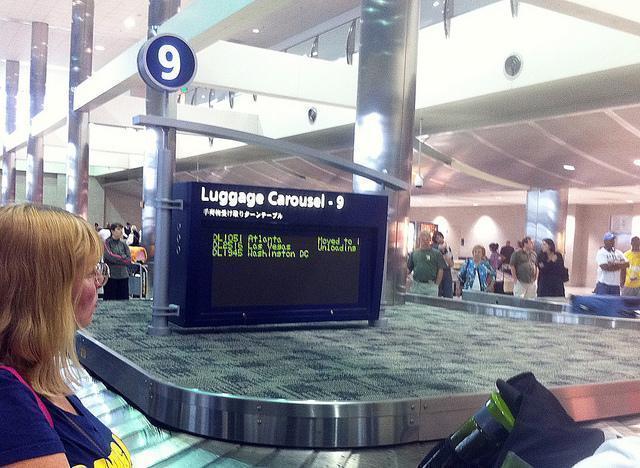What country's cities are listed on the information board?
From the following four choices, select the correct answer to address the question.
Options: Mexico, united states, england, brazil. United states. 